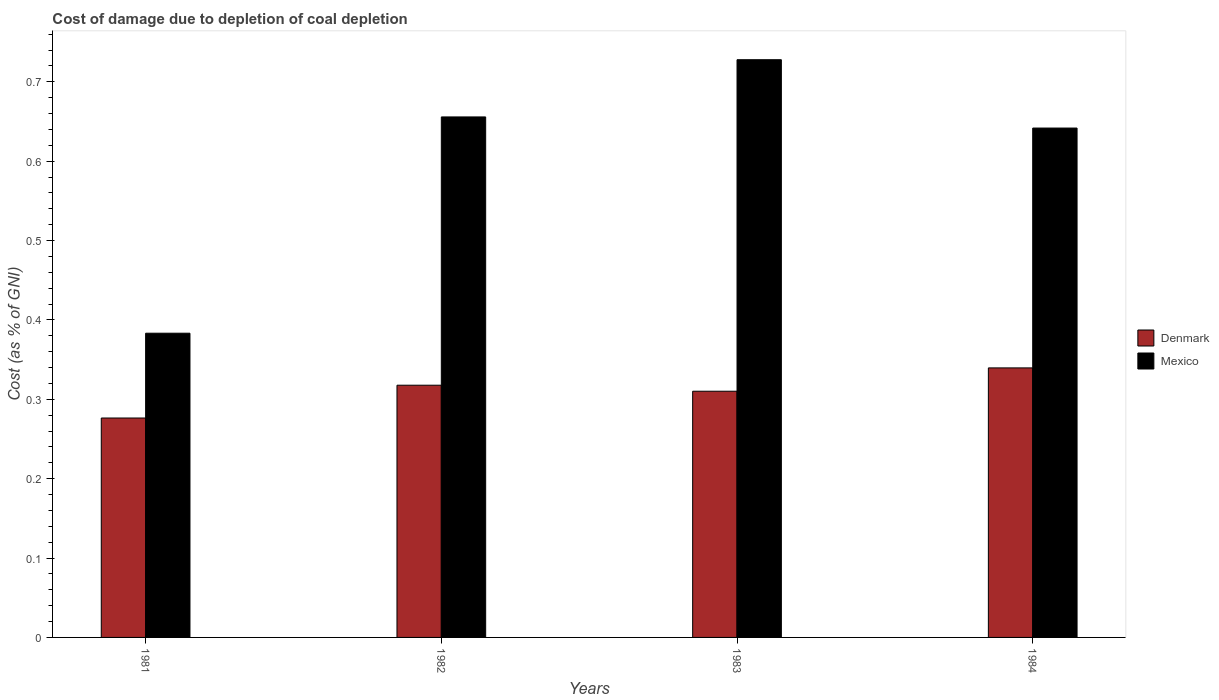How many different coloured bars are there?
Offer a very short reply. 2. How many bars are there on the 3rd tick from the left?
Provide a succinct answer. 2. How many bars are there on the 2nd tick from the right?
Offer a terse response. 2. What is the label of the 2nd group of bars from the left?
Your response must be concise. 1982. In how many cases, is the number of bars for a given year not equal to the number of legend labels?
Offer a very short reply. 0. What is the cost of damage caused due to coal depletion in Mexico in 1982?
Your answer should be very brief. 0.66. Across all years, what is the maximum cost of damage caused due to coal depletion in Mexico?
Give a very brief answer. 0.73. Across all years, what is the minimum cost of damage caused due to coal depletion in Mexico?
Provide a succinct answer. 0.38. What is the total cost of damage caused due to coal depletion in Mexico in the graph?
Give a very brief answer. 2.41. What is the difference between the cost of damage caused due to coal depletion in Denmark in 1982 and that in 1983?
Give a very brief answer. 0.01. What is the difference between the cost of damage caused due to coal depletion in Mexico in 1981 and the cost of damage caused due to coal depletion in Denmark in 1983?
Your response must be concise. 0.07. What is the average cost of damage caused due to coal depletion in Denmark per year?
Your answer should be very brief. 0.31. In the year 1981, what is the difference between the cost of damage caused due to coal depletion in Denmark and cost of damage caused due to coal depletion in Mexico?
Keep it short and to the point. -0.11. In how many years, is the cost of damage caused due to coal depletion in Mexico greater than 0.2 %?
Provide a succinct answer. 4. What is the ratio of the cost of damage caused due to coal depletion in Mexico in 1981 to that in 1982?
Ensure brevity in your answer.  0.58. Is the cost of damage caused due to coal depletion in Mexico in 1982 less than that in 1984?
Your response must be concise. No. Is the difference between the cost of damage caused due to coal depletion in Denmark in 1981 and 1984 greater than the difference between the cost of damage caused due to coal depletion in Mexico in 1981 and 1984?
Keep it short and to the point. Yes. What is the difference between the highest and the second highest cost of damage caused due to coal depletion in Denmark?
Your answer should be very brief. 0.02. What is the difference between the highest and the lowest cost of damage caused due to coal depletion in Denmark?
Provide a succinct answer. 0.06. In how many years, is the cost of damage caused due to coal depletion in Denmark greater than the average cost of damage caused due to coal depletion in Denmark taken over all years?
Your answer should be compact. 2. What does the 2nd bar from the right in 1983 represents?
Offer a terse response. Denmark. What is the difference between two consecutive major ticks on the Y-axis?
Your answer should be very brief. 0.1. Where does the legend appear in the graph?
Provide a short and direct response. Center right. How many legend labels are there?
Make the answer very short. 2. What is the title of the graph?
Make the answer very short. Cost of damage due to depletion of coal depletion. What is the label or title of the Y-axis?
Your answer should be very brief. Cost (as % of GNI). What is the Cost (as % of GNI) of Denmark in 1981?
Ensure brevity in your answer.  0.28. What is the Cost (as % of GNI) of Mexico in 1981?
Your response must be concise. 0.38. What is the Cost (as % of GNI) in Denmark in 1982?
Your answer should be very brief. 0.32. What is the Cost (as % of GNI) of Mexico in 1982?
Your response must be concise. 0.66. What is the Cost (as % of GNI) of Denmark in 1983?
Offer a terse response. 0.31. What is the Cost (as % of GNI) in Mexico in 1983?
Ensure brevity in your answer.  0.73. What is the Cost (as % of GNI) of Denmark in 1984?
Offer a very short reply. 0.34. What is the Cost (as % of GNI) in Mexico in 1984?
Your answer should be compact. 0.64. Across all years, what is the maximum Cost (as % of GNI) in Denmark?
Provide a short and direct response. 0.34. Across all years, what is the maximum Cost (as % of GNI) in Mexico?
Provide a short and direct response. 0.73. Across all years, what is the minimum Cost (as % of GNI) of Denmark?
Give a very brief answer. 0.28. Across all years, what is the minimum Cost (as % of GNI) of Mexico?
Make the answer very short. 0.38. What is the total Cost (as % of GNI) in Denmark in the graph?
Offer a terse response. 1.24. What is the total Cost (as % of GNI) of Mexico in the graph?
Your answer should be compact. 2.41. What is the difference between the Cost (as % of GNI) in Denmark in 1981 and that in 1982?
Ensure brevity in your answer.  -0.04. What is the difference between the Cost (as % of GNI) in Mexico in 1981 and that in 1982?
Offer a terse response. -0.27. What is the difference between the Cost (as % of GNI) in Denmark in 1981 and that in 1983?
Offer a very short reply. -0.03. What is the difference between the Cost (as % of GNI) of Mexico in 1981 and that in 1983?
Your answer should be compact. -0.34. What is the difference between the Cost (as % of GNI) of Denmark in 1981 and that in 1984?
Offer a very short reply. -0.06. What is the difference between the Cost (as % of GNI) of Mexico in 1981 and that in 1984?
Your answer should be very brief. -0.26. What is the difference between the Cost (as % of GNI) in Denmark in 1982 and that in 1983?
Provide a short and direct response. 0.01. What is the difference between the Cost (as % of GNI) of Mexico in 1982 and that in 1983?
Provide a short and direct response. -0.07. What is the difference between the Cost (as % of GNI) of Denmark in 1982 and that in 1984?
Keep it short and to the point. -0.02. What is the difference between the Cost (as % of GNI) in Mexico in 1982 and that in 1984?
Your response must be concise. 0.01. What is the difference between the Cost (as % of GNI) of Denmark in 1983 and that in 1984?
Offer a terse response. -0.03. What is the difference between the Cost (as % of GNI) in Mexico in 1983 and that in 1984?
Offer a very short reply. 0.09. What is the difference between the Cost (as % of GNI) of Denmark in 1981 and the Cost (as % of GNI) of Mexico in 1982?
Your response must be concise. -0.38. What is the difference between the Cost (as % of GNI) of Denmark in 1981 and the Cost (as % of GNI) of Mexico in 1983?
Ensure brevity in your answer.  -0.45. What is the difference between the Cost (as % of GNI) in Denmark in 1981 and the Cost (as % of GNI) in Mexico in 1984?
Make the answer very short. -0.37. What is the difference between the Cost (as % of GNI) of Denmark in 1982 and the Cost (as % of GNI) of Mexico in 1983?
Keep it short and to the point. -0.41. What is the difference between the Cost (as % of GNI) of Denmark in 1982 and the Cost (as % of GNI) of Mexico in 1984?
Give a very brief answer. -0.32. What is the difference between the Cost (as % of GNI) in Denmark in 1983 and the Cost (as % of GNI) in Mexico in 1984?
Your response must be concise. -0.33. What is the average Cost (as % of GNI) of Denmark per year?
Your answer should be compact. 0.31. What is the average Cost (as % of GNI) in Mexico per year?
Provide a short and direct response. 0.6. In the year 1981, what is the difference between the Cost (as % of GNI) of Denmark and Cost (as % of GNI) of Mexico?
Offer a very short reply. -0.11. In the year 1982, what is the difference between the Cost (as % of GNI) in Denmark and Cost (as % of GNI) in Mexico?
Keep it short and to the point. -0.34. In the year 1983, what is the difference between the Cost (as % of GNI) of Denmark and Cost (as % of GNI) of Mexico?
Give a very brief answer. -0.42. In the year 1984, what is the difference between the Cost (as % of GNI) in Denmark and Cost (as % of GNI) in Mexico?
Offer a terse response. -0.3. What is the ratio of the Cost (as % of GNI) in Denmark in 1981 to that in 1982?
Provide a short and direct response. 0.87. What is the ratio of the Cost (as % of GNI) in Mexico in 1981 to that in 1982?
Provide a succinct answer. 0.58. What is the ratio of the Cost (as % of GNI) of Denmark in 1981 to that in 1983?
Offer a terse response. 0.89. What is the ratio of the Cost (as % of GNI) in Mexico in 1981 to that in 1983?
Provide a short and direct response. 0.53. What is the ratio of the Cost (as % of GNI) of Denmark in 1981 to that in 1984?
Make the answer very short. 0.81. What is the ratio of the Cost (as % of GNI) in Mexico in 1981 to that in 1984?
Offer a very short reply. 0.6. What is the ratio of the Cost (as % of GNI) of Denmark in 1982 to that in 1983?
Provide a short and direct response. 1.02. What is the ratio of the Cost (as % of GNI) of Mexico in 1982 to that in 1983?
Give a very brief answer. 0.9. What is the ratio of the Cost (as % of GNI) of Denmark in 1982 to that in 1984?
Offer a very short reply. 0.94. What is the ratio of the Cost (as % of GNI) in Mexico in 1982 to that in 1984?
Keep it short and to the point. 1.02. What is the ratio of the Cost (as % of GNI) of Denmark in 1983 to that in 1984?
Make the answer very short. 0.91. What is the ratio of the Cost (as % of GNI) in Mexico in 1983 to that in 1984?
Provide a short and direct response. 1.13. What is the difference between the highest and the second highest Cost (as % of GNI) in Denmark?
Ensure brevity in your answer.  0.02. What is the difference between the highest and the second highest Cost (as % of GNI) of Mexico?
Provide a short and direct response. 0.07. What is the difference between the highest and the lowest Cost (as % of GNI) of Denmark?
Ensure brevity in your answer.  0.06. What is the difference between the highest and the lowest Cost (as % of GNI) in Mexico?
Provide a succinct answer. 0.34. 